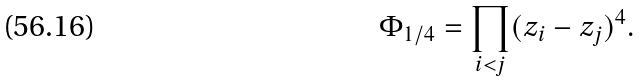<formula> <loc_0><loc_0><loc_500><loc_500>\Phi _ { 1 / 4 } = \prod _ { i < j } ( z _ { i } - z _ { j } ) ^ { 4 } .</formula> 